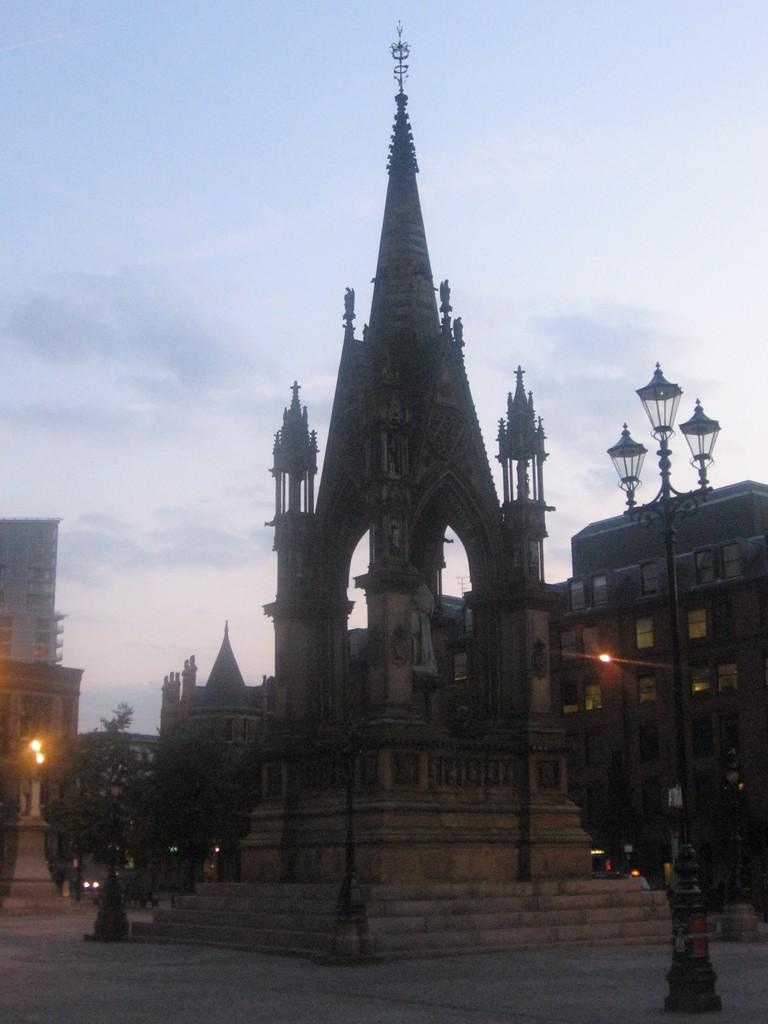What type of structure is present in the image? There is a building in the image. What other objects can be seen in the image? There is a street light pole and a tree visible in the image. What can be seen in the background of the image? There are lights, trees, buildings, and vehicles on the road visible in the background of the image. What part of the natural environment is visible in the image? The sky is visible in the background of the image. What is the income of the person who owns the building in the image? There is no information about the income of the person who owns the building in the image. What type of lead can be seen in the image? There is no lead present in the image. 